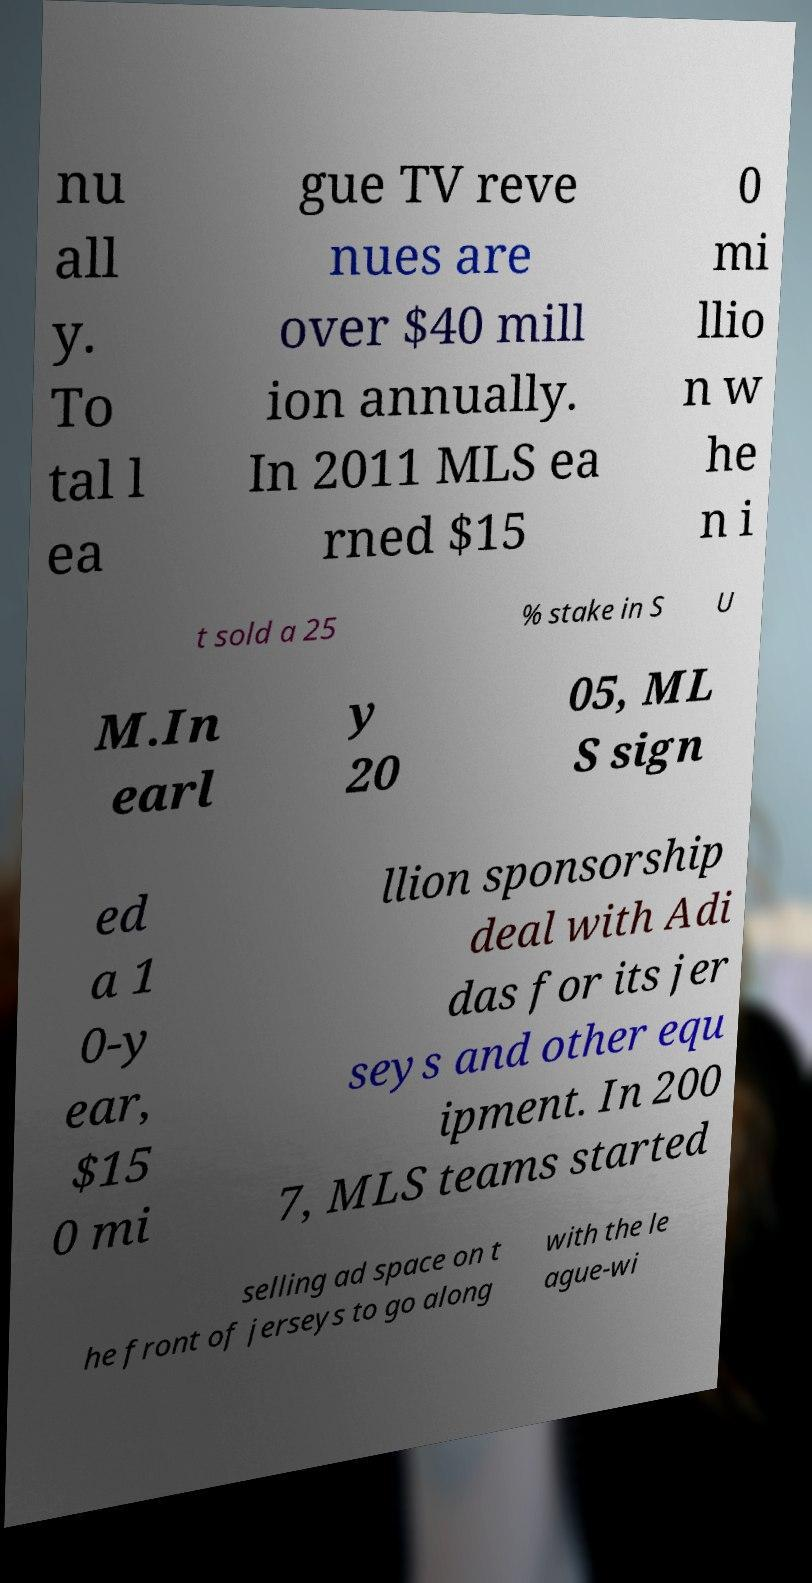Please read and relay the text visible in this image. What does it say? nu all y. To tal l ea gue TV reve nues are over $40 mill ion annually. In 2011 MLS ea rned $15 0 mi llio n w he n i t sold a 25 % stake in S U M.In earl y 20 05, ML S sign ed a 1 0-y ear, $15 0 mi llion sponsorship deal with Adi das for its jer seys and other equ ipment. In 200 7, MLS teams started selling ad space on t he front of jerseys to go along with the le ague-wi 